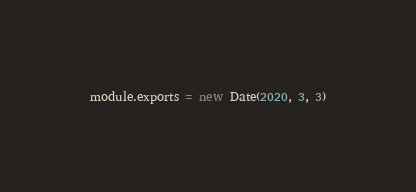<code> <loc_0><loc_0><loc_500><loc_500><_JavaScript_>module.exports = new Date(2020, 3, 3)
</code> 